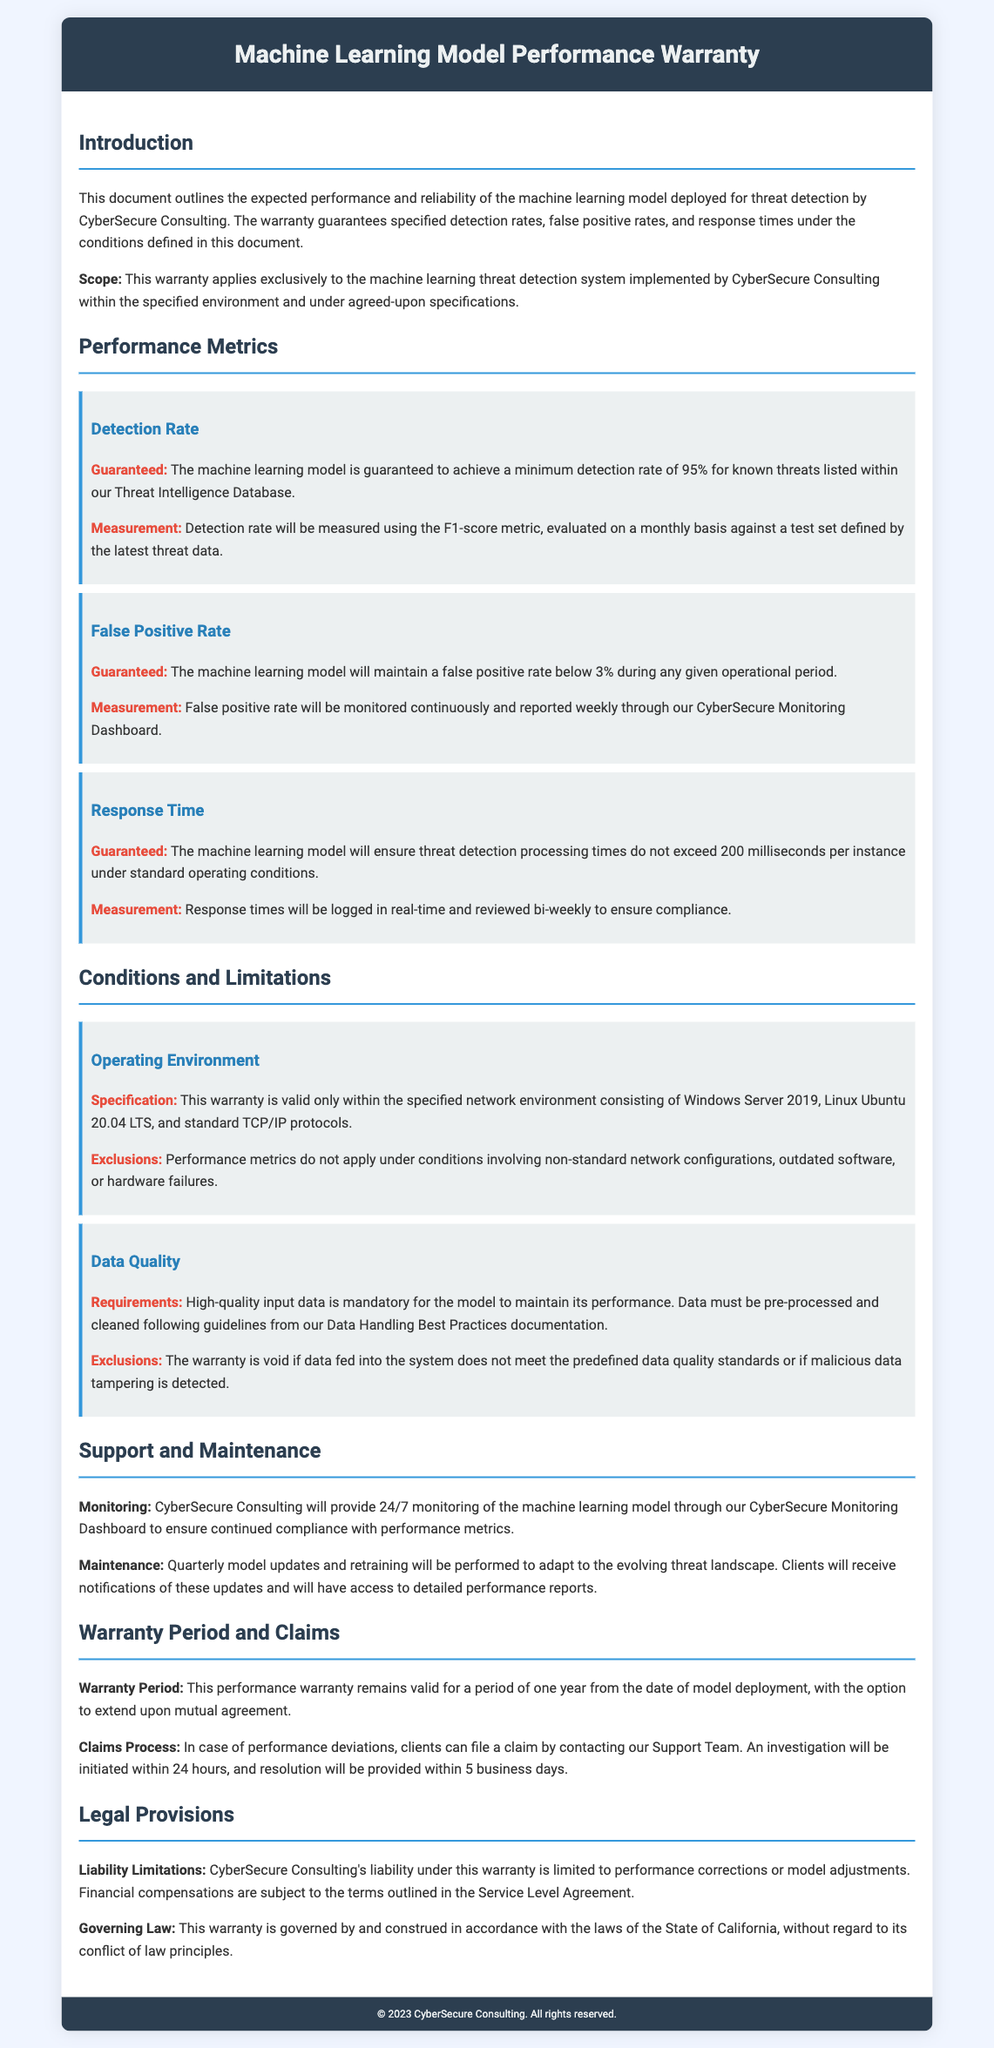What is the minimum guaranteed detection rate? The warranty specifies a minimum detection rate of 95% for known threats.
Answer: 95% What is the false positive rate guarantee? The document states that the false positive rate will be maintained below 3%.
Answer: Below 3% What is the maximum response time allowed? The model's threat detection processing times should not exceed 200 milliseconds per instance.
Answer: 200 milliseconds How often will the detection rate be measured? The detection rate will be evaluated on a monthly basis.
Answer: Monthly What conditions will void the warranty? The warranty is void if data fed into the system does not meet the predefined data quality standards.
Answer: Data quality standards What is the warranty period? The performance warranty is valid for a period of one year from the date of model deployment.
Answer: One year What software environments does the warranty apply to? The warranty applies exclusively within Windows Server 2019 and Linux Ubuntu 20.04 LTS environments.
Answer: Windows Server 2019, Linux Ubuntu 20.04 LTS How will clients be notified of model updates? Clients will receive notifications of the quarterly model updates and retraining.
Answer: Notifications What is CyberSecure Consulting’s liability under this warranty? CyberSecure Consulting's liability is limited to performance corrections or model adjustments.
Answer: Performance corrections or model adjustments 